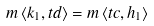<formula> <loc_0><loc_0><loc_500><loc_500>m \left \langle k _ { 1 } , t d \right \rangle = m \left \langle t c , h _ { 1 } \right \rangle</formula> 